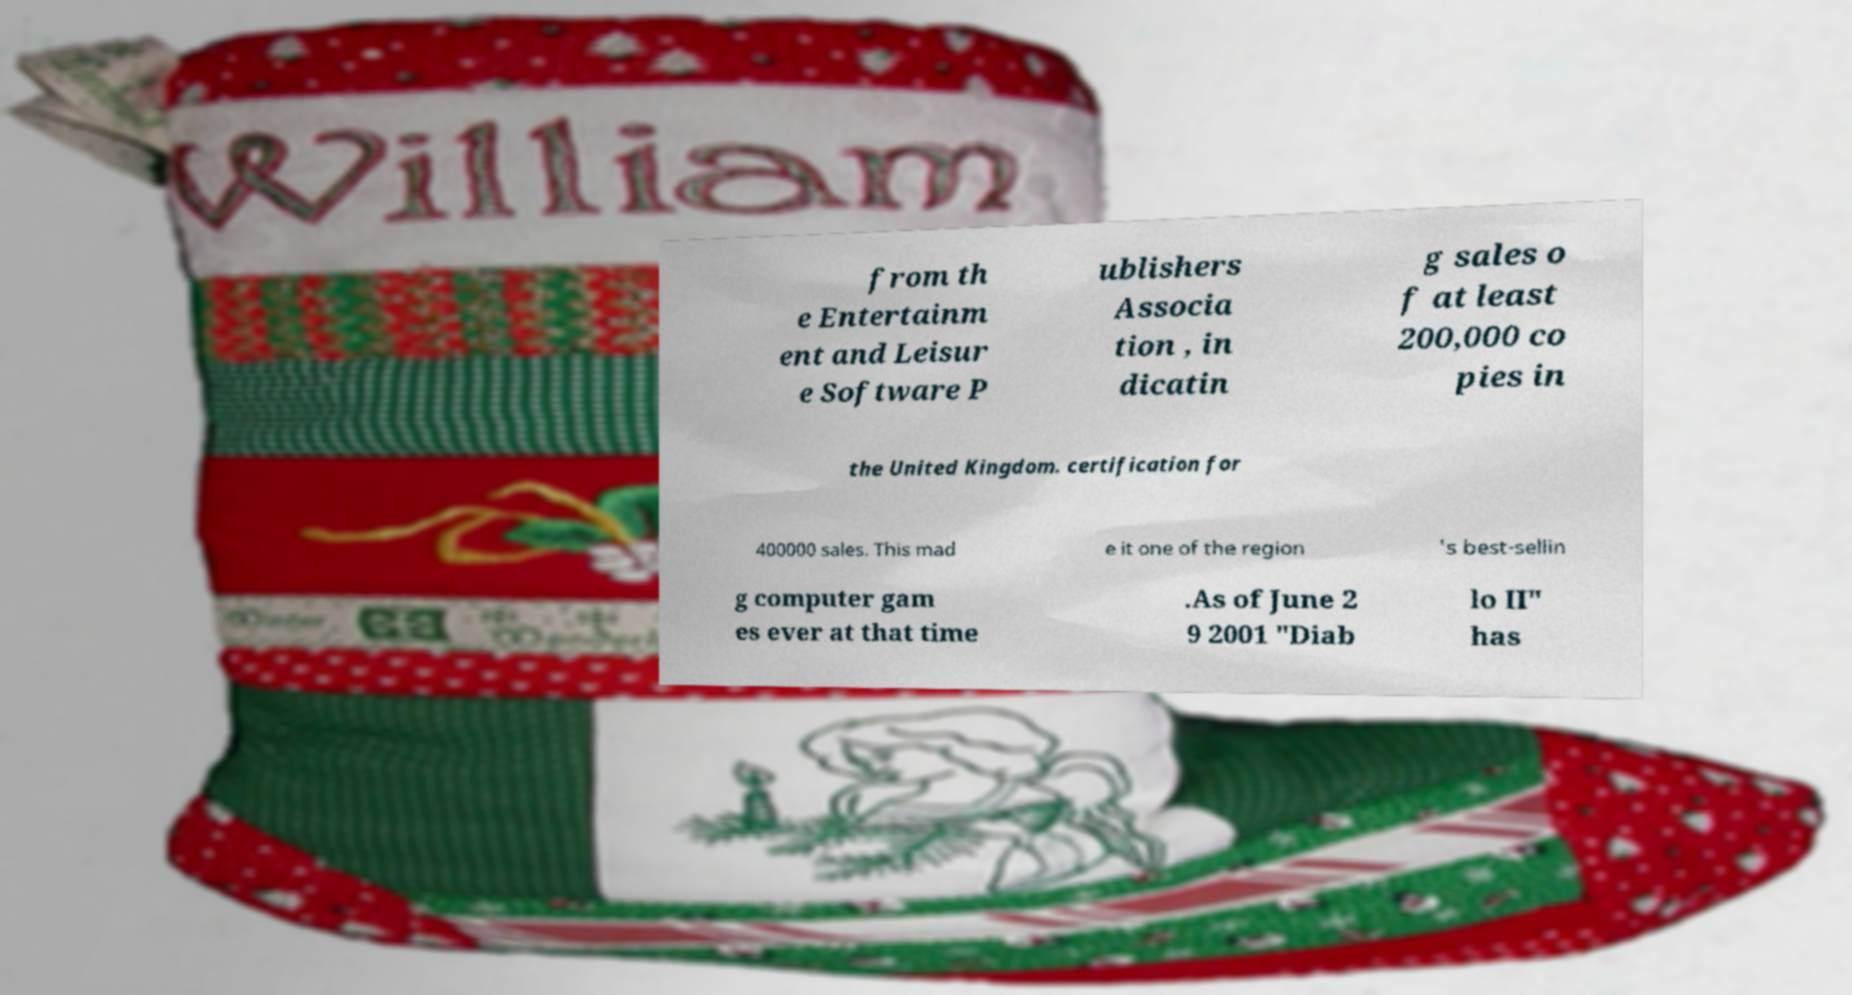Could you extract and type out the text from this image? from th e Entertainm ent and Leisur e Software P ublishers Associa tion , in dicatin g sales o f at least 200,000 co pies in the United Kingdom. certification for 400000 sales. This mad e it one of the region 's best-sellin g computer gam es ever at that time .As of June 2 9 2001 "Diab lo II" has 